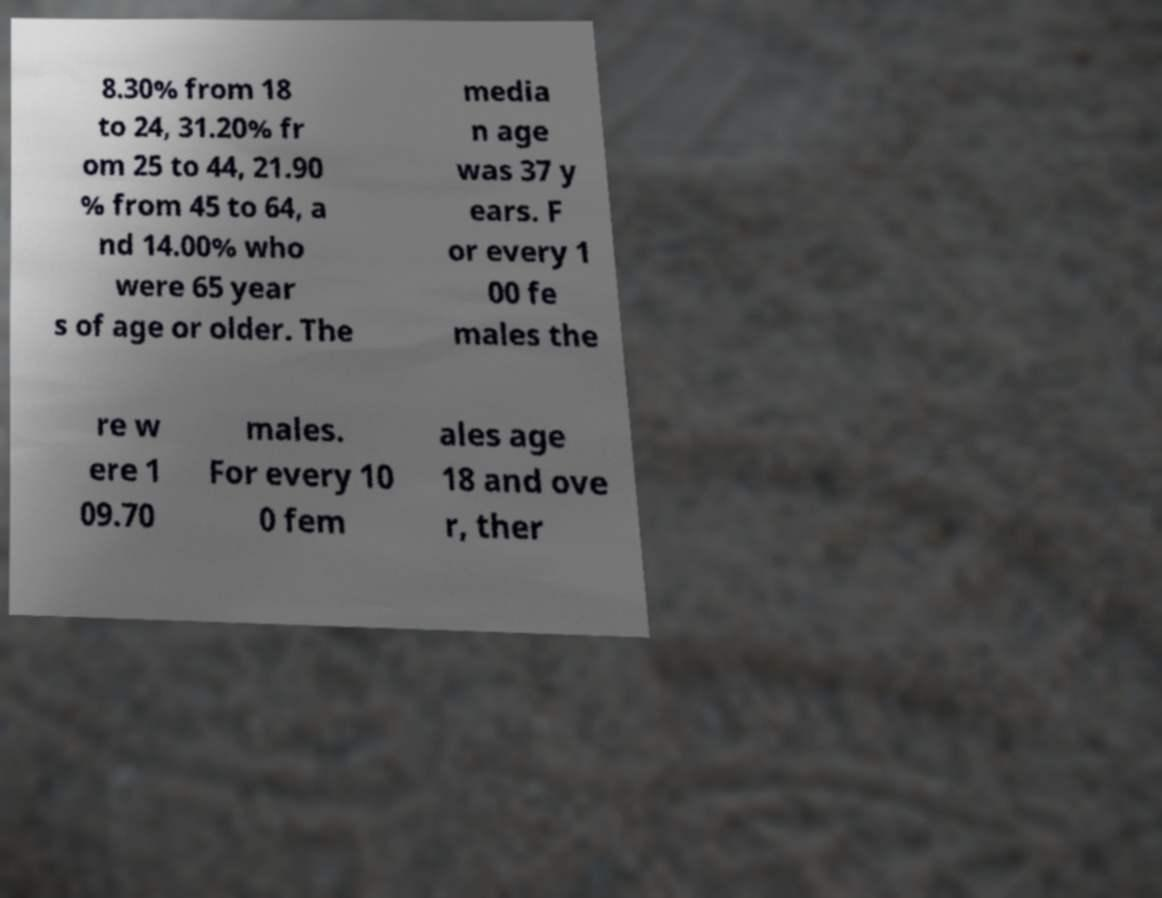Can you read and provide the text displayed in the image?This photo seems to have some interesting text. Can you extract and type it out for me? 8.30% from 18 to 24, 31.20% fr om 25 to 44, 21.90 % from 45 to 64, a nd 14.00% who were 65 year s of age or older. The media n age was 37 y ears. F or every 1 00 fe males the re w ere 1 09.70 males. For every 10 0 fem ales age 18 and ove r, ther 